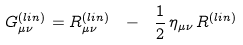Convert formula to latex. <formula><loc_0><loc_0><loc_500><loc_500>G _ { \mu \nu } ^ { ( l i n ) } = R _ { \mu \nu } ^ { ( l i n ) } \ - \ \frac { 1 } { 2 } \, \eta _ { \mu \nu } \, R ^ { ( l i n ) }</formula> 